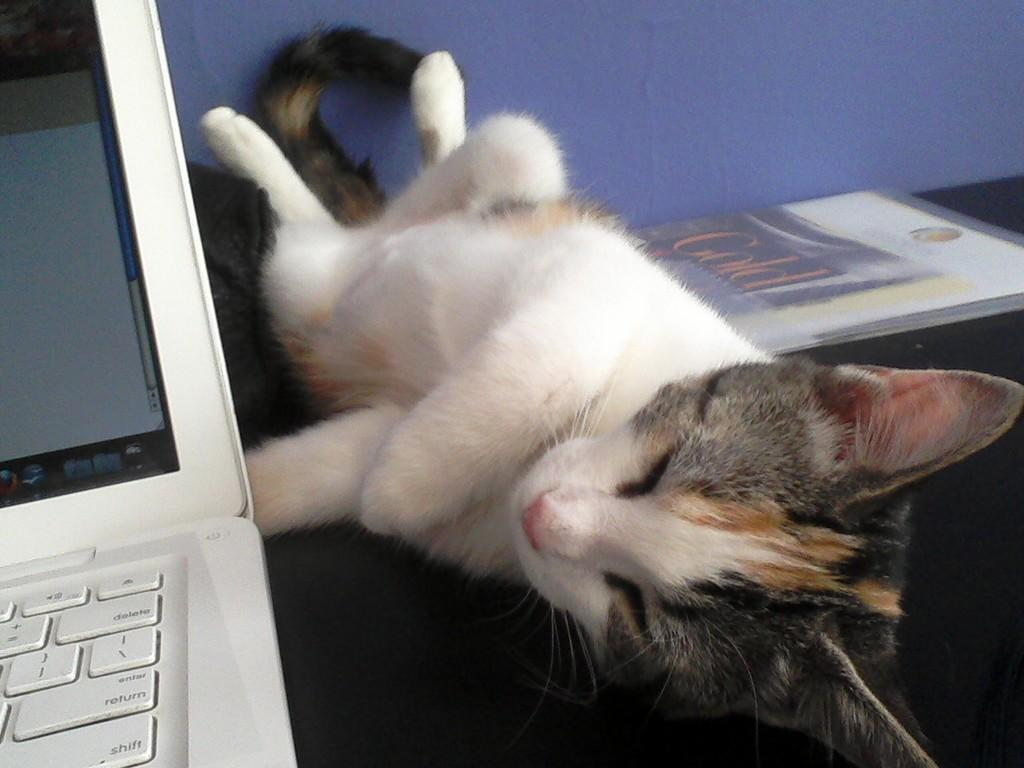What electronic device is visible in the image? There is a laptop in the image. What color is the laptop? The laptop is white. What type of animal is present in the image? There is a cat in the image. What colors does the cat have? The cat is white and has other colors. What type of quiver is visible in the image? There is no quiver present in the image. Is there a lamp visible in the image? The provided facts do not mention a lamp, so we cannot determine if one is present in the image. 